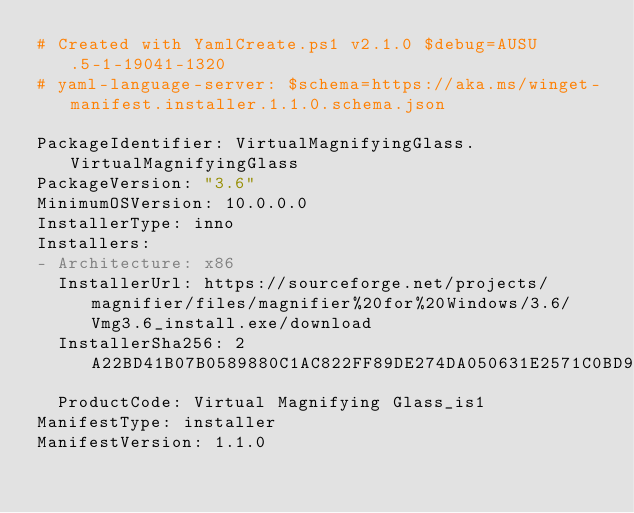<code> <loc_0><loc_0><loc_500><loc_500><_YAML_># Created with YamlCreate.ps1 v2.1.0 $debug=AUSU.5-1-19041-1320
# yaml-language-server: $schema=https://aka.ms/winget-manifest.installer.1.1.0.schema.json

PackageIdentifier: VirtualMagnifyingGlass.VirtualMagnifyingGlass
PackageVersion: "3.6"
MinimumOSVersion: 10.0.0.0
InstallerType: inno
Installers:
- Architecture: x86
  InstallerUrl: https://sourceforge.net/projects/magnifier/files/magnifier%20for%20Windows/3.6/Vmg3.6_install.exe/download
  InstallerSha256: 2A22BD41B07B0589880C1AC822FF89DE274DA050631E2571C0BD9DA4697FFDF7
  ProductCode: Virtual Magnifying Glass_is1
ManifestType: installer
ManifestVersion: 1.1.0
</code> 